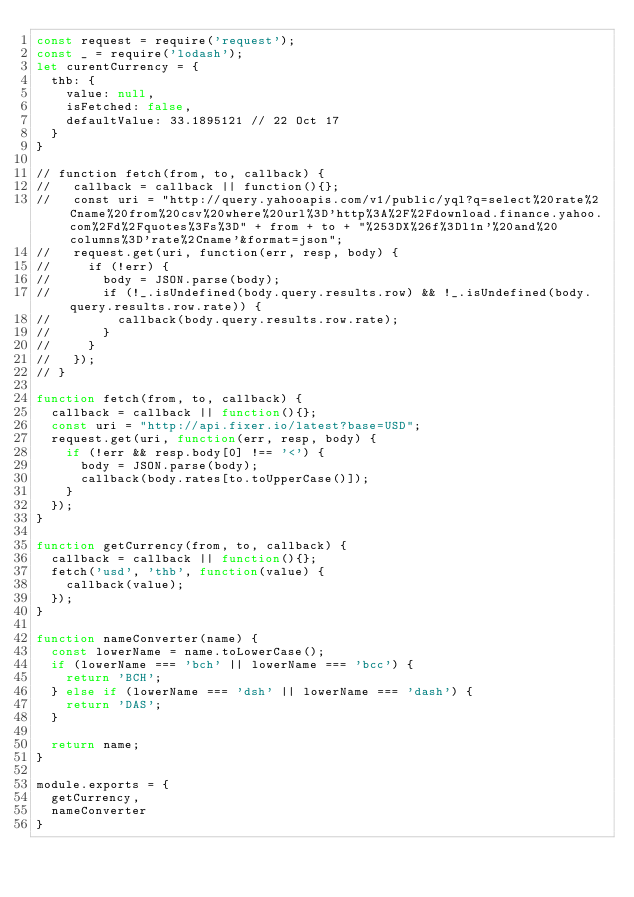Convert code to text. <code><loc_0><loc_0><loc_500><loc_500><_JavaScript_>const request = require('request');
const _ = require('lodash');
let curentCurrency = {
  thb: {
    value: null,
    isFetched: false,
    defaultValue: 33.1895121 // 22 Oct 17
  }
}

// function fetch(from, to, callback) {
//   callback = callback || function(){};
//   const uri = "http://query.yahooapis.com/v1/public/yql?q=select%20rate%2Cname%20from%20csv%20where%20url%3D'http%3A%2F%2Fdownload.finance.yahoo.com%2Fd%2Fquotes%3Fs%3D" + from + to + "%253DX%26f%3Dl1n'%20and%20columns%3D'rate%2Cname'&format=json";
//   request.get(uri, function(err, resp, body) {
//     if (!err) {
//       body = JSON.parse(body);
//       if (!_.isUndefined(body.query.results.row) && !_.isUndefined(body.query.results.row.rate)) {
//         callback(body.query.results.row.rate);
//       }
//     }
//   });
// }

function fetch(from, to, callback) {
  callback = callback || function(){};
  const uri = "http://api.fixer.io/latest?base=USD";
  request.get(uri, function(err, resp, body) {
    if (!err && resp.body[0] !== '<') {
      body = JSON.parse(body);
      callback(body.rates[to.toUpperCase()]);
    }
  });
}

function getCurrency(from, to, callback) {
  callback = callback || function(){};
  fetch('usd', 'thb', function(value) {       
    callback(value);
  });
}

function nameConverter(name) {
  const lowerName = name.toLowerCase();
  if (lowerName === 'bch' || lowerName === 'bcc') {
    return 'BCH';
  } else if (lowerName === 'dsh' || lowerName === 'dash') {
    return 'DAS';
  }

  return name;
}

module.exports = {
  getCurrency,
  nameConverter
}
</code> 